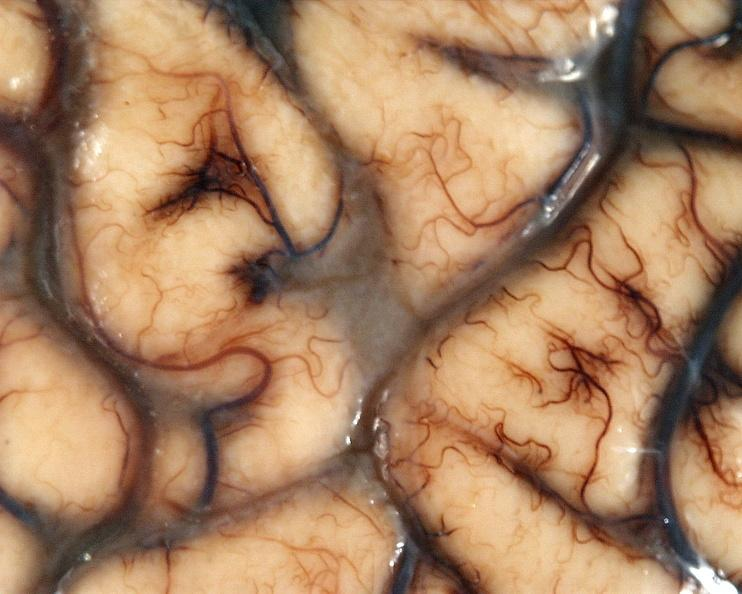s nervous present?
Answer the question using a single word or phrase. Yes 